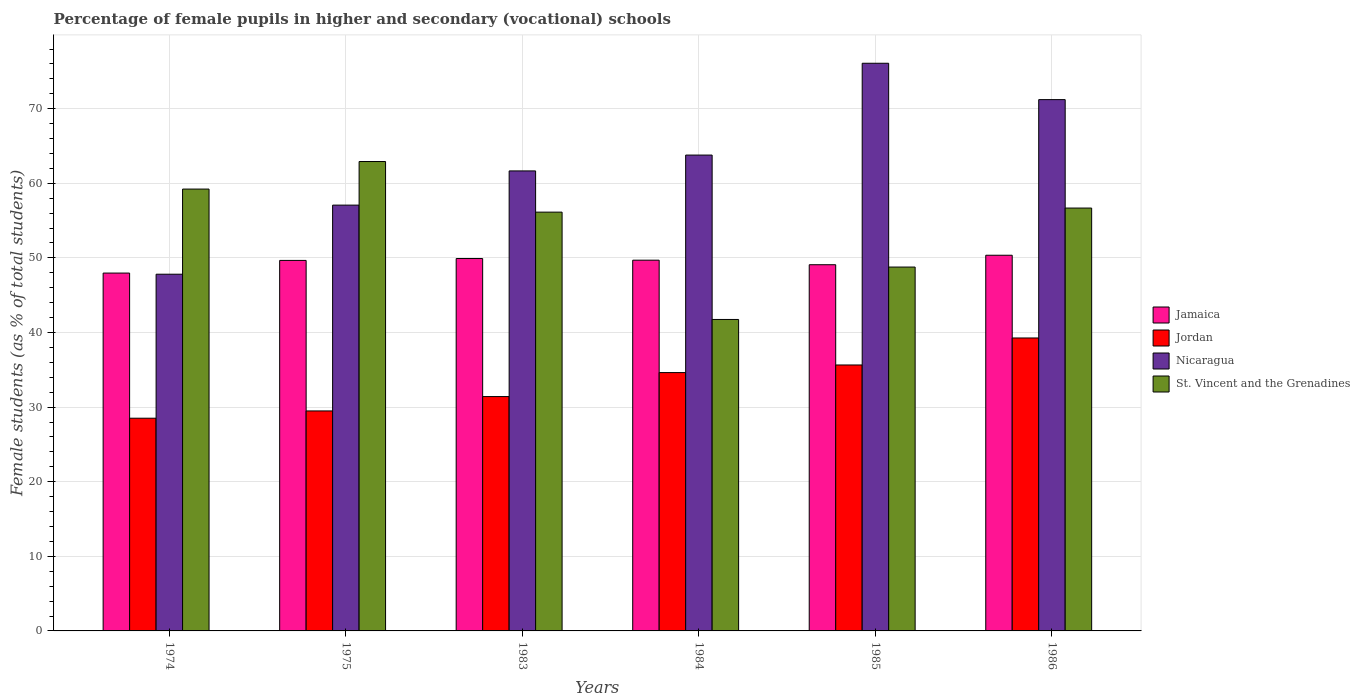How many different coloured bars are there?
Provide a succinct answer. 4. How many groups of bars are there?
Your answer should be very brief. 6. Are the number of bars per tick equal to the number of legend labels?
Give a very brief answer. Yes. Are the number of bars on each tick of the X-axis equal?
Offer a terse response. Yes. How many bars are there on the 6th tick from the left?
Provide a short and direct response. 4. How many bars are there on the 5th tick from the right?
Provide a succinct answer. 4. What is the label of the 2nd group of bars from the left?
Offer a very short reply. 1975. What is the percentage of female pupils in higher and secondary schools in Jamaica in 1975?
Your answer should be very brief. 49.66. Across all years, what is the maximum percentage of female pupils in higher and secondary schools in Jordan?
Your response must be concise. 39.27. Across all years, what is the minimum percentage of female pupils in higher and secondary schools in Jamaica?
Make the answer very short. 47.97. In which year was the percentage of female pupils in higher and secondary schools in Nicaragua minimum?
Ensure brevity in your answer.  1974. What is the total percentage of female pupils in higher and secondary schools in St. Vincent and the Grenadines in the graph?
Make the answer very short. 325.48. What is the difference between the percentage of female pupils in higher and secondary schools in St. Vincent and the Grenadines in 1975 and that in 1985?
Make the answer very short. 14.15. What is the difference between the percentage of female pupils in higher and secondary schools in Jamaica in 1974 and the percentage of female pupils in higher and secondary schools in Jordan in 1984?
Ensure brevity in your answer.  13.34. What is the average percentage of female pupils in higher and secondary schools in Nicaragua per year?
Provide a short and direct response. 62.94. In the year 1975, what is the difference between the percentage of female pupils in higher and secondary schools in Jordan and percentage of female pupils in higher and secondary schools in St. Vincent and the Grenadines?
Keep it short and to the point. -33.43. In how many years, is the percentage of female pupils in higher and secondary schools in Jamaica greater than 24 %?
Ensure brevity in your answer.  6. What is the ratio of the percentage of female pupils in higher and secondary schools in St. Vincent and the Grenadines in 1974 to that in 1986?
Your response must be concise. 1.04. Is the percentage of female pupils in higher and secondary schools in Nicaragua in 1974 less than that in 1986?
Offer a very short reply. Yes. Is the difference between the percentage of female pupils in higher and secondary schools in Jordan in 1974 and 1984 greater than the difference between the percentage of female pupils in higher and secondary schools in St. Vincent and the Grenadines in 1974 and 1984?
Ensure brevity in your answer.  No. What is the difference between the highest and the second highest percentage of female pupils in higher and secondary schools in Jordan?
Your response must be concise. 3.62. What is the difference between the highest and the lowest percentage of female pupils in higher and secondary schools in St. Vincent and the Grenadines?
Give a very brief answer. 21.17. Is the sum of the percentage of female pupils in higher and secondary schools in Jamaica in 1984 and 1986 greater than the maximum percentage of female pupils in higher and secondary schools in St. Vincent and the Grenadines across all years?
Your answer should be compact. Yes. Is it the case that in every year, the sum of the percentage of female pupils in higher and secondary schools in Nicaragua and percentage of female pupils in higher and secondary schools in Jamaica is greater than the sum of percentage of female pupils in higher and secondary schools in Jordan and percentage of female pupils in higher and secondary schools in St. Vincent and the Grenadines?
Give a very brief answer. No. What does the 2nd bar from the left in 1984 represents?
Make the answer very short. Jordan. What does the 3rd bar from the right in 1985 represents?
Your response must be concise. Jordan. Is it the case that in every year, the sum of the percentage of female pupils in higher and secondary schools in St. Vincent and the Grenadines and percentage of female pupils in higher and secondary schools in Jamaica is greater than the percentage of female pupils in higher and secondary schools in Nicaragua?
Your response must be concise. Yes. Are all the bars in the graph horizontal?
Ensure brevity in your answer.  No. What is the difference between two consecutive major ticks on the Y-axis?
Your answer should be very brief. 10. Does the graph contain any zero values?
Ensure brevity in your answer.  No. Does the graph contain grids?
Offer a terse response. Yes. How many legend labels are there?
Provide a short and direct response. 4. What is the title of the graph?
Provide a succinct answer. Percentage of female pupils in higher and secondary (vocational) schools. What is the label or title of the X-axis?
Your answer should be compact. Years. What is the label or title of the Y-axis?
Your response must be concise. Female students (as % of total students). What is the Female students (as % of total students) of Jamaica in 1974?
Provide a short and direct response. 47.97. What is the Female students (as % of total students) in Jordan in 1974?
Your answer should be very brief. 28.51. What is the Female students (as % of total students) in Nicaragua in 1974?
Offer a very short reply. 47.81. What is the Female students (as % of total students) in St. Vincent and the Grenadines in 1974?
Offer a terse response. 59.23. What is the Female students (as % of total students) of Jamaica in 1975?
Keep it short and to the point. 49.66. What is the Female students (as % of total students) of Jordan in 1975?
Ensure brevity in your answer.  29.49. What is the Female students (as % of total students) in Nicaragua in 1975?
Offer a terse response. 57.07. What is the Female students (as % of total students) of St. Vincent and the Grenadines in 1975?
Your answer should be compact. 62.92. What is the Female students (as % of total students) in Jamaica in 1983?
Your response must be concise. 49.92. What is the Female students (as % of total students) of Jordan in 1983?
Offer a very short reply. 31.41. What is the Female students (as % of total students) of Nicaragua in 1983?
Keep it short and to the point. 61.66. What is the Female students (as % of total students) of St. Vincent and the Grenadines in 1983?
Keep it short and to the point. 56.13. What is the Female students (as % of total students) in Jamaica in 1984?
Offer a very short reply. 49.69. What is the Female students (as % of total students) of Jordan in 1984?
Offer a terse response. 34.63. What is the Female students (as % of total students) in Nicaragua in 1984?
Make the answer very short. 63.78. What is the Female students (as % of total students) in St. Vincent and the Grenadines in 1984?
Keep it short and to the point. 41.75. What is the Female students (as % of total students) of Jamaica in 1985?
Keep it short and to the point. 49.09. What is the Female students (as % of total students) of Jordan in 1985?
Keep it short and to the point. 35.65. What is the Female students (as % of total students) of Nicaragua in 1985?
Your answer should be very brief. 76.09. What is the Female students (as % of total students) of St. Vincent and the Grenadines in 1985?
Ensure brevity in your answer.  48.77. What is the Female students (as % of total students) of Jamaica in 1986?
Your response must be concise. 50.36. What is the Female students (as % of total students) in Jordan in 1986?
Keep it short and to the point. 39.27. What is the Female students (as % of total students) in Nicaragua in 1986?
Make the answer very short. 71.22. What is the Female students (as % of total students) of St. Vincent and the Grenadines in 1986?
Your answer should be compact. 56.68. Across all years, what is the maximum Female students (as % of total students) of Jamaica?
Your answer should be very brief. 50.36. Across all years, what is the maximum Female students (as % of total students) of Jordan?
Your answer should be very brief. 39.27. Across all years, what is the maximum Female students (as % of total students) in Nicaragua?
Ensure brevity in your answer.  76.09. Across all years, what is the maximum Female students (as % of total students) of St. Vincent and the Grenadines?
Provide a short and direct response. 62.92. Across all years, what is the minimum Female students (as % of total students) of Jamaica?
Offer a terse response. 47.97. Across all years, what is the minimum Female students (as % of total students) in Jordan?
Provide a short and direct response. 28.51. Across all years, what is the minimum Female students (as % of total students) of Nicaragua?
Give a very brief answer. 47.81. Across all years, what is the minimum Female students (as % of total students) in St. Vincent and the Grenadines?
Offer a very short reply. 41.75. What is the total Female students (as % of total students) of Jamaica in the graph?
Keep it short and to the point. 296.68. What is the total Female students (as % of total students) in Jordan in the graph?
Offer a terse response. 198.95. What is the total Female students (as % of total students) in Nicaragua in the graph?
Provide a succinct answer. 377.64. What is the total Female students (as % of total students) in St. Vincent and the Grenadines in the graph?
Make the answer very short. 325.48. What is the difference between the Female students (as % of total students) in Jamaica in 1974 and that in 1975?
Ensure brevity in your answer.  -1.7. What is the difference between the Female students (as % of total students) in Jordan in 1974 and that in 1975?
Your answer should be compact. -0.97. What is the difference between the Female students (as % of total students) of Nicaragua in 1974 and that in 1975?
Make the answer very short. -9.26. What is the difference between the Female students (as % of total students) in St. Vincent and the Grenadines in 1974 and that in 1975?
Give a very brief answer. -3.69. What is the difference between the Female students (as % of total students) of Jamaica in 1974 and that in 1983?
Make the answer very short. -1.95. What is the difference between the Female students (as % of total students) of Jordan in 1974 and that in 1983?
Provide a succinct answer. -2.9. What is the difference between the Female students (as % of total students) of Nicaragua in 1974 and that in 1983?
Your answer should be compact. -13.84. What is the difference between the Female students (as % of total students) of St. Vincent and the Grenadines in 1974 and that in 1983?
Give a very brief answer. 3.09. What is the difference between the Female students (as % of total students) in Jamaica in 1974 and that in 1984?
Provide a succinct answer. -1.73. What is the difference between the Female students (as % of total students) of Jordan in 1974 and that in 1984?
Keep it short and to the point. -6.11. What is the difference between the Female students (as % of total students) in Nicaragua in 1974 and that in 1984?
Give a very brief answer. -15.97. What is the difference between the Female students (as % of total students) in St. Vincent and the Grenadines in 1974 and that in 1984?
Your answer should be compact. 17.48. What is the difference between the Female students (as % of total students) in Jamaica in 1974 and that in 1985?
Offer a very short reply. -1.12. What is the difference between the Female students (as % of total students) in Jordan in 1974 and that in 1985?
Make the answer very short. -7.14. What is the difference between the Female students (as % of total students) of Nicaragua in 1974 and that in 1985?
Your response must be concise. -28.28. What is the difference between the Female students (as % of total students) in St. Vincent and the Grenadines in 1974 and that in 1985?
Provide a short and direct response. 10.45. What is the difference between the Female students (as % of total students) of Jamaica in 1974 and that in 1986?
Your response must be concise. -2.39. What is the difference between the Female students (as % of total students) in Jordan in 1974 and that in 1986?
Make the answer very short. -10.76. What is the difference between the Female students (as % of total students) in Nicaragua in 1974 and that in 1986?
Your answer should be compact. -23.4. What is the difference between the Female students (as % of total students) of St. Vincent and the Grenadines in 1974 and that in 1986?
Your response must be concise. 2.55. What is the difference between the Female students (as % of total students) in Jamaica in 1975 and that in 1983?
Offer a very short reply. -0.25. What is the difference between the Female students (as % of total students) of Jordan in 1975 and that in 1983?
Offer a terse response. -1.93. What is the difference between the Female students (as % of total students) in Nicaragua in 1975 and that in 1983?
Ensure brevity in your answer.  -4.58. What is the difference between the Female students (as % of total students) of St. Vincent and the Grenadines in 1975 and that in 1983?
Provide a short and direct response. 6.78. What is the difference between the Female students (as % of total students) in Jamaica in 1975 and that in 1984?
Your answer should be very brief. -0.03. What is the difference between the Female students (as % of total students) of Jordan in 1975 and that in 1984?
Give a very brief answer. -5.14. What is the difference between the Female students (as % of total students) in Nicaragua in 1975 and that in 1984?
Keep it short and to the point. -6.71. What is the difference between the Female students (as % of total students) in St. Vincent and the Grenadines in 1975 and that in 1984?
Make the answer very short. 21.17. What is the difference between the Female students (as % of total students) in Jamaica in 1975 and that in 1985?
Give a very brief answer. 0.58. What is the difference between the Female students (as % of total students) in Jordan in 1975 and that in 1985?
Offer a terse response. -6.16. What is the difference between the Female students (as % of total students) of Nicaragua in 1975 and that in 1985?
Make the answer very short. -19.01. What is the difference between the Female students (as % of total students) of St. Vincent and the Grenadines in 1975 and that in 1985?
Provide a short and direct response. 14.15. What is the difference between the Female students (as % of total students) of Jamaica in 1975 and that in 1986?
Your answer should be compact. -0.69. What is the difference between the Female students (as % of total students) in Jordan in 1975 and that in 1986?
Offer a terse response. -9.78. What is the difference between the Female students (as % of total students) of Nicaragua in 1975 and that in 1986?
Keep it short and to the point. -14.14. What is the difference between the Female students (as % of total students) of St. Vincent and the Grenadines in 1975 and that in 1986?
Your answer should be very brief. 6.24. What is the difference between the Female students (as % of total students) in Jamaica in 1983 and that in 1984?
Ensure brevity in your answer.  0.22. What is the difference between the Female students (as % of total students) in Jordan in 1983 and that in 1984?
Offer a terse response. -3.21. What is the difference between the Female students (as % of total students) of Nicaragua in 1983 and that in 1984?
Your answer should be very brief. -2.12. What is the difference between the Female students (as % of total students) in St. Vincent and the Grenadines in 1983 and that in 1984?
Provide a short and direct response. 14.39. What is the difference between the Female students (as % of total students) of Jamaica in 1983 and that in 1985?
Provide a succinct answer. 0.83. What is the difference between the Female students (as % of total students) of Jordan in 1983 and that in 1985?
Offer a very short reply. -4.23. What is the difference between the Female students (as % of total students) of Nicaragua in 1983 and that in 1985?
Keep it short and to the point. -14.43. What is the difference between the Female students (as % of total students) in St. Vincent and the Grenadines in 1983 and that in 1985?
Ensure brevity in your answer.  7.36. What is the difference between the Female students (as % of total students) of Jamaica in 1983 and that in 1986?
Offer a very short reply. -0.44. What is the difference between the Female students (as % of total students) of Jordan in 1983 and that in 1986?
Provide a short and direct response. -7.85. What is the difference between the Female students (as % of total students) in Nicaragua in 1983 and that in 1986?
Keep it short and to the point. -9.56. What is the difference between the Female students (as % of total students) of St. Vincent and the Grenadines in 1983 and that in 1986?
Make the answer very short. -0.55. What is the difference between the Female students (as % of total students) of Jamaica in 1984 and that in 1985?
Ensure brevity in your answer.  0.61. What is the difference between the Female students (as % of total students) in Jordan in 1984 and that in 1985?
Your answer should be compact. -1.02. What is the difference between the Female students (as % of total students) of Nicaragua in 1984 and that in 1985?
Keep it short and to the point. -12.31. What is the difference between the Female students (as % of total students) in St. Vincent and the Grenadines in 1984 and that in 1985?
Give a very brief answer. -7.02. What is the difference between the Female students (as % of total students) of Jamaica in 1984 and that in 1986?
Your response must be concise. -0.66. What is the difference between the Female students (as % of total students) of Jordan in 1984 and that in 1986?
Your answer should be compact. -4.64. What is the difference between the Female students (as % of total students) of Nicaragua in 1984 and that in 1986?
Keep it short and to the point. -7.43. What is the difference between the Female students (as % of total students) in St. Vincent and the Grenadines in 1984 and that in 1986?
Your answer should be compact. -14.93. What is the difference between the Female students (as % of total students) in Jamaica in 1985 and that in 1986?
Your answer should be compact. -1.27. What is the difference between the Female students (as % of total students) in Jordan in 1985 and that in 1986?
Provide a succinct answer. -3.62. What is the difference between the Female students (as % of total students) in Nicaragua in 1985 and that in 1986?
Give a very brief answer. 4.87. What is the difference between the Female students (as % of total students) of St. Vincent and the Grenadines in 1985 and that in 1986?
Make the answer very short. -7.91. What is the difference between the Female students (as % of total students) of Jamaica in 1974 and the Female students (as % of total students) of Jordan in 1975?
Keep it short and to the point. 18.48. What is the difference between the Female students (as % of total students) in Jamaica in 1974 and the Female students (as % of total students) in Nicaragua in 1975?
Keep it short and to the point. -9.11. What is the difference between the Female students (as % of total students) of Jamaica in 1974 and the Female students (as % of total students) of St. Vincent and the Grenadines in 1975?
Your answer should be compact. -14.95. What is the difference between the Female students (as % of total students) of Jordan in 1974 and the Female students (as % of total students) of Nicaragua in 1975?
Give a very brief answer. -28.56. What is the difference between the Female students (as % of total students) of Jordan in 1974 and the Female students (as % of total students) of St. Vincent and the Grenadines in 1975?
Your answer should be very brief. -34.41. What is the difference between the Female students (as % of total students) in Nicaragua in 1974 and the Female students (as % of total students) in St. Vincent and the Grenadines in 1975?
Offer a terse response. -15.1. What is the difference between the Female students (as % of total students) of Jamaica in 1974 and the Female students (as % of total students) of Jordan in 1983?
Offer a very short reply. 16.55. What is the difference between the Female students (as % of total students) of Jamaica in 1974 and the Female students (as % of total students) of Nicaragua in 1983?
Ensure brevity in your answer.  -13.69. What is the difference between the Female students (as % of total students) in Jamaica in 1974 and the Female students (as % of total students) in St. Vincent and the Grenadines in 1983?
Ensure brevity in your answer.  -8.17. What is the difference between the Female students (as % of total students) of Jordan in 1974 and the Female students (as % of total students) of Nicaragua in 1983?
Ensure brevity in your answer.  -33.15. What is the difference between the Female students (as % of total students) in Jordan in 1974 and the Female students (as % of total students) in St. Vincent and the Grenadines in 1983?
Offer a terse response. -27.62. What is the difference between the Female students (as % of total students) of Nicaragua in 1974 and the Female students (as % of total students) of St. Vincent and the Grenadines in 1983?
Keep it short and to the point. -8.32. What is the difference between the Female students (as % of total students) in Jamaica in 1974 and the Female students (as % of total students) in Jordan in 1984?
Offer a very short reply. 13.34. What is the difference between the Female students (as % of total students) of Jamaica in 1974 and the Female students (as % of total students) of Nicaragua in 1984?
Offer a terse response. -15.82. What is the difference between the Female students (as % of total students) of Jamaica in 1974 and the Female students (as % of total students) of St. Vincent and the Grenadines in 1984?
Offer a very short reply. 6.22. What is the difference between the Female students (as % of total students) in Jordan in 1974 and the Female students (as % of total students) in Nicaragua in 1984?
Give a very brief answer. -35.27. What is the difference between the Female students (as % of total students) of Jordan in 1974 and the Female students (as % of total students) of St. Vincent and the Grenadines in 1984?
Make the answer very short. -13.24. What is the difference between the Female students (as % of total students) in Nicaragua in 1974 and the Female students (as % of total students) in St. Vincent and the Grenadines in 1984?
Offer a terse response. 6.07. What is the difference between the Female students (as % of total students) of Jamaica in 1974 and the Female students (as % of total students) of Jordan in 1985?
Provide a short and direct response. 12.32. What is the difference between the Female students (as % of total students) of Jamaica in 1974 and the Female students (as % of total students) of Nicaragua in 1985?
Provide a short and direct response. -28.12. What is the difference between the Female students (as % of total students) of Jamaica in 1974 and the Female students (as % of total students) of St. Vincent and the Grenadines in 1985?
Make the answer very short. -0.81. What is the difference between the Female students (as % of total students) of Jordan in 1974 and the Female students (as % of total students) of Nicaragua in 1985?
Keep it short and to the point. -47.58. What is the difference between the Female students (as % of total students) in Jordan in 1974 and the Female students (as % of total students) in St. Vincent and the Grenadines in 1985?
Provide a short and direct response. -20.26. What is the difference between the Female students (as % of total students) in Nicaragua in 1974 and the Female students (as % of total students) in St. Vincent and the Grenadines in 1985?
Your answer should be compact. -0.96. What is the difference between the Female students (as % of total students) in Jamaica in 1974 and the Female students (as % of total students) in Jordan in 1986?
Give a very brief answer. 8.7. What is the difference between the Female students (as % of total students) of Jamaica in 1974 and the Female students (as % of total students) of Nicaragua in 1986?
Offer a very short reply. -23.25. What is the difference between the Female students (as % of total students) of Jamaica in 1974 and the Female students (as % of total students) of St. Vincent and the Grenadines in 1986?
Your answer should be compact. -8.71. What is the difference between the Female students (as % of total students) in Jordan in 1974 and the Female students (as % of total students) in Nicaragua in 1986?
Your answer should be very brief. -42.7. What is the difference between the Female students (as % of total students) in Jordan in 1974 and the Female students (as % of total students) in St. Vincent and the Grenadines in 1986?
Your answer should be very brief. -28.17. What is the difference between the Female students (as % of total students) of Nicaragua in 1974 and the Female students (as % of total students) of St. Vincent and the Grenadines in 1986?
Provide a succinct answer. -8.87. What is the difference between the Female students (as % of total students) of Jamaica in 1975 and the Female students (as % of total students) of Jordan in 1983?
Provide a succinct answer. 18.25. What is the difference between the Female students (as % of total students) in Jamaica in 1975 and the Female students (as % of total students) in Nicaragua in 1983?
Keep it short and to the point. -12. What is the difference between the Female students (as % of total students) of Jamaica in 1975 and the Female students (as % of total students) of St. Vincent and the Grenadines in 1983?
Keep it short and to the point. -6.47. What is the difference between the Female students (as % of total students) of Jordan in 1975 and the Female students (as % of total students) of Nicaragua in 1983?
Keep it short and to the point. -32.17. What is the difference between the Female students (as % of total students) of Jordan in 1975 and the Female students (as % of total students) of St. Vincent and the Grenadines in 1983?
Keep it short and to the point. -26.65. What is the difference between the Female students (as % of total students) in Nicaragua in 1975 and the Female students (as % of total students) in St. Vincent and the Grenadines in 1983?
Offer a terse response. 0.94. What is the difference between the Female students (as % of total students) of Jamaica in 1975 and the Female students (as % of total students) of Jordan in 1984?
Give a very brief answer. 15.04. What is the difference between the Female students (as % of total students) in Jamaica in 1975 and the Female students (as % of total students) in Nicaragua in 1984?
Offer a terse response. -14.12. What is the difference between the Female students (as % of total students) of Jamaica in 1975 and the Female students (as % of total students) of St. Vincent and the Grenadines in 1984?
Give a very brief answer. 7.92. What is the difference between the Female students (as % of total students) of Jordan in 1975 and the Female students (as % of total students) of Nicaragua in 1984?
Make the answer very short. -34.3. What is the difference between the Female students (as % of total students) in Jordan in 1975 and the Female students (as % of total students) in St. Vincent and the Grenadines in 1984?
Offer a terse response. -12.26. What is the difference between the Female students (as % of total students) in Nicaragua in 1975 and the Female students (as % of total students) in St. Vincent and the Grenadines in 1984?
Ensure brevity in your answer.  15.33. What is the difference between the Female students (as % of total students) of Jamaica in 1975 and the Female students (as % of total students) of Jordan in 1985?
Your response must be concise. 14.02. What is the difference between the Female students (as % of total students) in Jamaica in 1975 and the Female students (as % of total students) in Nicaragua in 1985?
Provide a succinct answer. -26.43. What is the difference between the Female students (as % of total students) of Jamaica in 1975 and the Female students (as % of total students) of St. Vincent and the Grenadines in 1985?
Your answer should be compact. 0.89. What is the difference between the Female students (as % of total students) of Jordan in 1975 and the Female students (as % of total students) of Nicaragua in 1985?
Provide a short and direct response. -46.6. What is the difference between the Female students (as % of total students) in Jordan in 1975 and the Female students (as % of total students) in St. Vincent and the Grenadines in 1985?
Offer a terse response. -19.29. What is the difference between the Female students (as % of total students) in Nicaragua in 1975 and the Female students (as % of total students) in St. Vincent and the Grenadines in 1985?
Your answer should be compact. 8.3. What is the difference between the Female students (as % of total students) in Jamaica in 1975 and the Female students (as % of total students) in Jordan in 1986?
Give a very brief answer. 10.4. What is the difference between the Female students (as % of total students) in Jamaica in 1975 and the Female students (as % of total students) in Nicaragua in 1986?
Offer a terse response. -21.55. What is the difference between the Female students (as % of total students) in Jamaica in 1975 and the Female students (as % of total students) in St. Vincent and the Grenadines in 1986?
Your response must be concise. -7.02. What is the difference between the Female students (as % of total students) in Jordan in 1975 and the Female students (as % of total students) in Nicaragua in 1986?
Provide a short and direct response. -41.73. What is the difference between the Female students (as % of total students) in Jordan in 1975 and the Female students (as % of total students) in St. Vincent and the Grenadines in 1986?
Your answer should be compact. -27.19. What is the difference between the Female students (as % of total students) of Nicaragua in 1975 and the Female students (as % of total students) of St. Vincent and the Grenadines in 1986?
Keep it short and to the point. 0.39. What is the difference between the Female students (as % of total students) of Jamaica in 1983 and the Female students (as % of total students) of Jordan in 1984?
Ensure brevity in your answer.  15.29. What is the difference between the Female students (as % of total students) of Jamaica in 1983 and the Female students (as % of total students) of Nicaragua in 1984?
Your response must be concise. -13.87. What is the difference between the Female students (as % of total students) in Jamaica in 1983 and the Female students (as % of total students) in St. Vincent and the Grenadines in 1984?
Give a very brief answer. 8.17. What is the difference between the Female students (as % of total students) in Jordan in 1983 and the Female students (as % of total students) in Nicaragua in 1984?
Keep it short and to the point. -32.37. What is the difference between the Female students (as % of total students) in Jordan in 1983 and the Female students (as % of total students) in St. Vincent and the Grenadines in 1984?
Your response must be concise. -10.33. What is the difference between the Female students (as % of total students) of Nicaragua in 1983 and the Female students (as % of total students) of St. Vincent and the Grenadines in 1984?
Your answer should be compact. 19.91. What is the difference between the Female students (as % of total students) in Jamaica in 1983 and the Female students (as % of total students) in Jordan in 1985?
Your response must be concise. 14.27. What is the difference between the Female students (as % of total students) of Jamaica in 1983 and the Female students (as % of total students) of Nicaragua in 1985?
Ensure brevity in your answer.  -26.17. What is the difference between the Female students (as % of total students) of Jamaica in 1983 and the Female students (as % of total students) of St. Vincent and the Grenadines in 1985?
Your answer should be very brief. 1.14. What is the difference between the Female students (as % of total students) of Jordan in 1983 and the Female students (as % of total students) of Nicaragua in 1985?
Ensure brevity in your answer.  -44.68. What is the difference between the Female students (as % of total students) of Jordan in 1983 and the Female students (as % of total students) of St. Vincent and the Grenadines in 1985?
Keep it short and to the point. -17.36. What is the difference between the Female students (as % of total students) in Nicaragua in 1983 and the Female students (as % of total students) in St. Vincent and the Grenadines in 1985?
Provide a short and direct response. 12.89. What is the difference between the Female students (as % of total students) in Jamaica in 1983 and the Female students (as % of total students) in Jordan in 1986?
Provide a short and direct response. 10.65. What is the difference between the Female students (as % of total students) in Jamaica in 1983 and the Female students (as % of total students) in Nicaragua in 1986?
Offer a terse response. -21.3. What is the difference between the Female students (as % of total students) in Jamaica in 1983 and the Female students (as % of total students) in St. Vincent and the Grenadines in 1986?
Make the answer very short. -6.76. What is the difference between the Female students (as % of total students) in Jordan in 1983 and the Female students (as % of total students) in Nicaragua in 1986?
Make the answer very short. -39.8. What is the difference between the Female students (as % of total students) in Jordan in 1983 and the Female students (as % of total students) in St. Vincent and the Grenadines in 1986?
Keep it short and to the point. -25.27. What is the difference between the Female students (as % of total students) in Nicaragua in 1983 and the Female students (as % of total students) in St. Vincent and the Grenadines in 1986?
Offer a very short reply. 4.98. What is the difference between the Female students (as % of total students) in Jamaica in 1984 and the Female students (as % of total students) in Jordan in 1985?
Provide a short and direct response. 14.05. What is the difference between the Female students (as % of total students) of Jamaica in 1984 and the Female students (as % of total students) of Nicaragua in 1985?
Your response must be concise. -26.4. What is the difference between the Female students (as % of total students) of Jamaica in 1984 and the Female students (as % of total students) of St. Vincent and the Grenadines in 1985?
Your answer should be very brief. 0.92. What is the difference between the Female students (as % of total students) in Jordan in 1984 and the Female students (as % of total students) in Nicaragua in 1985?
Keep it short and to the point. -41.46. What is the difference between the Female students (as % of total students) of Jordan in 1984 and the Female students (as % of total students) of St. Vincent and the Grenadines in 1985?
Provide a short and direct response. -14.15. What is the difference between the Female students (as % of total students) in Nicaragua in 1984 and the Female students (as % of total students) in St. Vincent and the Grenadines in 1985?
Offer a very short reply. 15.01. What is the difference between the Female students (as % of total students) in Jamaica in 1984 and the Female students (as % of total students) in Jordan in 1986?
Offer a terse response. 10.43. What is the difference between the Female students (as % of total students) in Jamaica in 1984 and the Female students (as % of total students) in Nicaragua in 1986?
Provide a short and direct response. -21.52. What is the difference between the Female students (as % of total students) of Jamaica in 1984 and the Female students (as % of total students) of St. Vincent and the Grenadines in 1986?
Provide a short and direct response. -6.99. What is the difference between the Female students (as % of total students) in Jordan in 1984 and the Female students (as % of total students) in Nicaragua in 1986?
Your answer should be compact. -36.59. What is the difference between the Female students (as % of total students) of Jordan in 1984 and the Female students (as % of total students) of St. Vincent and the Grenadines in 1986?
Offer a very short reply. -22.05. What is the difference between the Female students (as % of total students) of Nicaragua in 1984 and the Female students (as % of total students) of St. Vincent and the Grenadines in 1986?
Give a very brief answer. 7.1. What is the difference between the Female students (as % of total students) in Jamaica in 1985 and the Female students (as % of total students) in Jordan in 1986?
Make the answer very short. 9.82. What is the difference between the Female students (as % of total students) of Jamaica in 1985 and the Female students (as % of total students) of Nicaragua in 1986?
Keep it short and to the point. -22.13. What is the difference between the Female students (as % of total students) of Jamaica in 1985 and the Female students (as % of total students) of St. Vincent and the Grenadines in 1986?
Offer a very short reply. -7.59. What is the difference between the Female students (as % of total students) in Jordan in 1985 and the Female students (as % of total students) in Nicaragua in 1986?
Your response must be concise. -35.57. What is the difference between the Female students (as % of total students) of Jordan in 1985 and the Female students (as % of total students) of St. Vincent and the Grenadines in 1986?
Provide a short and direct response. -21.03. What is the difference between the Female students (as % of total students) of Nicaragua in 1985 and the Female students (as % of total students) of St. Vincent and the Grenadines in 1986?
Provide a succinct answer. 19.41. What is the average Female students (as % of total students) in Jamaica per year?
Your answer should be compact. 49.45. What is the average Female students (as % of total students) of Jordan per year?
Give a very brief answer. 33.16. What is the average Female students (as % of total students) of Nicaragua per year?
Offer a terse response. 62.94. What is the average Female students (as % of total students) in St. Vincent and the Grenadines per year?
Make the answer very short. 54.25. In the year 1974, what is the difference between the Female students (as % of total students) of Jamaica and Female students (as % of total students) of Jordan?
Offer a very short reply. 19.45. In the year 1974, what is the difference between the Female students (as % of total students) in Jamaica and Female students (as % of total students) in Nicaragua?
Ensure brevity in your answer.  0.15. In the year 1974, what is the difference between the Female students (as % of total students) in Jamaica and Female students (as % of total students) in St. Vincent and the Grenadines?
Provide a succinct answer. -11.26. In the year 1974, what is the difference between the Female students (as % of total students) in Jordan and Female students (as % of total students) in Nicaragua?
Ensure brevity in your answer.  -19.3. In the year 1974, what is the difference between the Female students (as % of total students) in Jordan and Female students (as % of total students) in St. Vincent and the Grenadines?
Your answer should be compact. -30.71. In the year 1974, what is the difference between the Female students (as % of total students) in Nicaragua and Female students (as % of total students) in St. Vincent and the Grenadines?
Ensure brevity in your answer.  -11.41. In the year 1975, what is the difference between the Female students (as % of total students) of Jamaica and Female students (as % of total students) of Jordan?
Ensure brevity in your answer.  20.18. In the year 1975, what is the difference between the Female students (as % of total students) of Jamaica and Female students (as % of total students) of Nicaragua?
Your answer should be compact. -7.41. In the year 1975, what is the difference between the Female students (as % of total students) of Jamaica and Female students (as % of total students) of St. Vincent and the Grenadines?
Provide a short and direct response. -13.26. In the year 1975, what is the difference between the Female students (as % of total students) of Jordan and Female students (as % of total students) of Nicaragua?
Give a very brief answer. -27.59. In the year 1975, what is the difference between the Female students (as % of total students) of Jordan and Female students (as % of total students) of St. Vincent and the Grenadines?
Provide a short and direct response. -33.43. In the year 1975, what is the difference between the Female students (as % of total students) in Nicaragua and Female students (as % of total students) in St. Vincent and the Grenadines?
Your answer should be very brief. -5.84. In the year 1983, what is the difference between the Female students (as % of total students) of Jamaica and Female students (as % of total students) of Jordan?
Provide a succinct answer. 18.5. In the year 1983, what is the difference between the Female students (as % of total students) of Jamaica and Female students (as % of total students) of Nicaragua?
Ensure brevity in your answer.  -11.74. In the year 1983, what is the difference between the Female students (as % of total students) in Jamaica and Female students (as % of total students) in St. Vincent and the Grenadines?
Provide a short and direct response. -6.22. In the year 1983, what is the difference between the Female students (as % of total students) of Jordan and Female students (as % of total students) of Nicaragua?
Provide a short and direct response. -30.25. In the year 1983, what is the difference between the Female students (as % of total students) of Jordan and Female students (as % of total students) of St. Vincent and the Grenadines?
Your response must be concise. -24.72. In the year 1983, what is the difference between the Female students (as % of total students) in Nicaragua and Female students (as % of total students) in St. Vincent and the Grenadines?
Provide a succinct answer. 5.52. In the year 1984, what is the difference between the Female students (as % of total students) in Jamaica and Female students (as % of total students) in Jordan?
Your answer should be very brief. 15.07. In the year 1984, what is the difference between the Female students (as % of total students) in Jamaica and Female students (as % of total students) in Nicaragua?
Ensure brevity in your answer.  -14.09. In the year 1984, what is the difference between the Female students (as % of total students) of Jamaica and Female students (as % of total students) of St. Vincent and the Grenadines?
Offer a very short reply. 7.95. In the year 1984, what is the difference between the Female students (as % of total students) of Jordan and Female students (as % of total students) of Nicaragua?
Keep it short and to the point. -29.16. In the year 1984, what is the difference between the Female students (as % of total students) of Jordan and Female students (as % of total students) of St. Vincent and the Grenadines?
Provide a succinct answer. -7.12. In the year 1984, what is the difference between the Female students (as % of total students) of Nicaragua and Female students (as % of total students) of St. Vincent and the Grenadines?
Keep it short and to the point. 22.04. In the year 1985, what is the difference between the Female students (as % of total students) in Jamaica and Female students (as % of total students) in Jordan?
Give a very brief answer. 13.44. In the year 1985, what is the difference between the Female students (as % of total students) of Jamaica and Female students (as % of total students) of Nicaragua?
Keep it short and to the point. -27. In the year 1985, what is the difference between the Female students (as % of total students) in Jamaica and Female students (as % of total students) in St. Vincent and the Grenadines?
Give a very brief answer. 0.31. In the year 1985, what is the difference between the Female students (as % of total students) in Jordan and Female students (as % of total students) in Nicaragua?
Make the answer very short. -40.44. In the year 1985, what is the difference between the Female students (as % of total students) of Jordan and Female students (as % of total students) of St. Vincent and the Grenadines?
Provide a short and direct response. -13.12. In the year 1985, what is the difference between the Female students (as % of total students) of Nicaragua and Female students (as % of total students) of St. Vincent and the Grenadines?
Keep it short and to the point. 27.32. In the year 1986, what is the difference between the Female students (as % of total students) of Jamaica and Female students (as % of total students) of Jordan?
Make the answer very short. 11.09. In the year 1986, what is the difference between the Female students (as % of total students) of Jamaica and Female students (as % of total students) of Nicaragua?
Provide a succinct answer. -20.86. In the year 1986, what is the difference between the Female students (as % of total students) of Jamaica and Female students (as % of total students) of St. Vincent and the Grenadines?
Give a very brief answer. -6.32. In the year 1986, what is the difference between the Female students (as % of total students) in Jordan and Female students (as % of total students) in Nicaragua?
Your response must be concise. -31.95. In the year 1986, what is the difference between the Female students (as % of total students) of Jordan and Female students (as % of total students) of St. Vincent and the Grenadines?
Your response must be concise. -17.41. In the year 1986, what is the difference between the Female students (as % of total students) of Nicaragua and Female students (as % of total students) of St. Vincent and the Grenadines?
Ensure brevity in your answer.  14.54. What is the ratio of the Female students (as % of total students) in Jamaica in 1974 to that in 1975?
Keep it short and to the point. 0.97. What is the ratio of the Female students (as % of total students) of Nicaragua in 1974 to that in 1975?
Your answer should be compact. 0.84. What is the ratio of the Female students (as % of total students) in St. Vincent and the Grenadines in 1974 to that in 1975?
Keep it short and to the point. 0.94. What is the ratio of the Female students (as % of total students) in Jamaica in 1974 to that in 1983?
Offer a terse response. 0.96. What is the ratio of the Female students (as % of total students) of Jordan in 1974 to that in 1983?
Make the answer very short. 0.91. What is the ratio of the Female students (as % of total students) of Nicaragua in 1974 to that in 1983?
Provide a succinct answer. 0.78. What is the ratio of the Female students (as % of total students) in St. Vincent and the Grenadines in 1974 to that in 1983?
Ensure brevity in your answer.  1.06. What is the ratio of the Female students (as % of total students) in Jamaica in 1974 to that in 1984?
Keep it short and to the point. 0.97. What is the ratio of the Female students (as % of total students) of Jordan in 1974 to that in 1984?
Keep it short and to the point. 0.82. What is the ratio of the Female students (as % of total students) of Nicaragua in 1974 to that in 1984?
Your answer should be very brief. 0.75. What is the ratio of the Female students (as % of total students) in St. Vincent and the Grenadines in 1974 to that in 1984?
Give a very brief answer. 1.42. What is the ratio of the Female students (as % of total students) in Jamaica in 1974 to that in 1985?
Make the answer very short. 0.98. What is the ratio of the Female students (as % of total students) of Jordan in 1974 to that in 1985?
Offer a very short reply. 0.8. What is the ratio of the Female students (as % of total students) of Nicaragua in 1974 to that in 1985?
Your response must be concise. 0.63. What is the ratio of the Female students (as % of total students) of St. Vincent and the Grenadines in 1974 to that in 1985?
Provide a succinct answer. 1.21. What is the ratio of the Female students (as % of total students) in Jamaica in 1974 to that in 1986?
Ensure brevity in your answer.  0.95. What is the ratio of the Female students (as % of total students) of Jordan in 1974 to that in 1986?
Provide a short and direct response. 0.73. What is the ratio of the Female students (as % of total students) in Nicaragua in 1974 to that in 1986?
Provide a short and direct response. 0.67. What is the ratio of the Female students (as % of total students) in St. Vincent and the Grenadines in 1974 to that in 1986?
Make the answer very short. 1.04. What is the ratio of the Female students (as % of total students) in Jordan in 1975 to that in 1983?
Keep it short and to the point. 0.94. What is the ratio of the Female students (as % of total students) in Nicaragua in 1975 to that in 1983?
Ensure brevity in your answer.  0.93. What is the ratio of the Female students (as % of total students) in St. Vincent and the Grenadines in 1975 to that in 1983?
Ensure brevity in your answer.  1.12. What is the ratio of the Female students (as % of total students) in Jordan in 1975 to that in 1984?
Ensure brevity in your answer.  0.85. What is the ratio of the Female students (as % of total students) in Nicaragua in 1975 to that in 1984?
Keep it short and to the point. 0.89. What is the ratio of the Female students (as % of total students) in St. Vincent and the Grenadines in 1975 to that in 1984?
Offer a terse response. 1.51. What is the ratio of the Female students (as % of total students) in Jamaica in 1975 to that in 1985?
Your answer should be very brief. 1.01. What is the ratio of the Female students (as % of total students) of Jordan in 1975 to that in 1985?
Provide a succinct answer. 0.83. What is the ratio of the Female students (as % of total students) in Nicaragua in 1975 to that in 1985?
Provide a succinct answer. 0.75. What is the ratio of the Female students (as % of total students) in St. Vincent and the Grenadines in 1975 to that in 1985?
Ensure brevity in your answer.  1.29. What is the ratio of the Female students (as % of total students) of Jamaica in 1975 to that in 1986?
Your answer should be very brief. 0.99. What is the ratio of the Female students (as % of total students) of Jordan in 1975 to that in 1986?
Provide a succinct answer. 0.75. What is the ratio of the Female students (as % of total students) in Nicaragua in 1975 to that in 1986?
Your answer should be compact. 0.8. What is the ratio of the Female students (as % of total students) of St. Vincent and the Grenadines in 1975 to that in 1986?
Provide a succinct answer. 1.11. What is the ratio of the Female students (as % of total students) of Jamaica in 1983 to that in 1984?
Provide a succinct answer. 1. What is the ratio of the Female students (as % of total students) in Jordan in 1983 to that in 1984?
Ensure brevity in your answer.  0.91. What is the ratio of the Female students (as % of total students) of Nicaragua in 1983 to that in 1984?
Offer a very short reply. 0.97. What is the ratio of the Female students (as % of total students) in St. Vincent and the Grenadines in 1983 to that in 1984?
Your response must be concise. 1.34. What is the ratio of the Female students (as % of total students) in Jamaica in 1983 to that in 1985?
Your answer should be very brief. 1.02. What is the ratio of the Female students (as % of total students) of Jordan in 1983 to that in 1985?
Provide a short and direct response. 0.88. What is the ratio of the Female students (as % of total students) of Nicaragua in 1983 to that in 1985?
Your answer should be very brief. 0.81. What is the ratio of the Female students (as % of total students) in St. Vincent and the Grenadines in 1983 to that in 1985?
Give a very brief answer. 1.15. What is the ratio of the Female students (as % of total students) in Jamaica in 1983 to that in 1986?
Keep it short and to the point. 0.99. What is the ratio of the Female students (as % of total students) in Nicaragua in 1983 to that in 1986?
Your answer should be compact. 0.87. What is the ratio of the Female students (as % of total students) in St. Vincent and the Grenadines in 1983 to that in 1986?
Offer a very short reply. 0.99. What is the ratio of the Female students (as % of total students) in Jamaica in 1984 to that in 1985?
Offer a terse response. 1.01. What is the ratio of the Female students (as % of total students) in Jordan in 1984 to that in 1985?
Keep it short and to the point. 0.97. What is the ratio of the Female students (as % of total students) of Nicaragua in 1984 to that in 1985?
Provide a short and direct response. 0.84. What is the ratio of the Female students (as % of total students) in St. Vincent and the Grenadines in 1984 to that in 1985?
Give a very brief answer. 0.86. What is the ratio of the Female students (as % of total students) of Jamaica in 1984 to that in 1986?
Provide a short and direct response. 0.99. What is the ratio of the Female students (as % of total students) in Jordan in 1984 to that in 1986?
Give a very brief answer. 0.88. What is the ratio of the Female students (as % of total students) of Nicaragua in 1984 to that in 1986?
Your answer should be very brief. 0.9. What is the ratio of the Female students (as % of total students) in St. Vincent and the Grenadines in 1984 to that in 1986?
Provide a succinct answer. 0.74. What is the ratio of the Female students (as % of total students) in Jamaica in 1985 to that in 1986?
Make the answer very short. 0.97. What is the ratio of the Female students (as % of total students) of Jordan in 1985 to that in 1986?
Your answer should be compact. 0.91. What is the ratio of the Female students (as % of total students) of Nicaragua in 1985 to that in 1986?
Make the answer very short. 1.07. What is the ratio of the Female students (as % of total students) of St. Vincent and the Grenadines in 1985 to that in 1986?
Your answer should be compact. 0.86. What is the difference between the highest and the second highest Female students (as % of total students) in Jamaica?
Your response must be concise. 0.44. What is the difference between the highest and the second highest Female students (as % of total students) of Jordan?
Keep it short and to the point. 3.62. What is the difference between the highest and the second highest Female students (as % of total students) of Nicaragua?
Offer a very short reply. 4.87. What is the difference between the highest and the second highest Female students (as % of total students) of St. Vincent and the Grenadines?
Your answer should be very brief. 3.69. What is the difference between the highest and the lowest Female students (as % of total students) in Jamaica?
Ensure brevity in your answer.  2.39. What is the difference between the highest and the lowest Female students (as % of total students) of Jordan?
Offer a very short reply. 10.76. What is the difference between the highest and the lowest Female students (as % of total students) of Nicaragua?
Ensure brevity in your answer.  28.28. What is the difference between the highest and the lowest Female students (as % of total students) in St. Vincent and the Grenadines?
Your response must be concise. 21.17. 